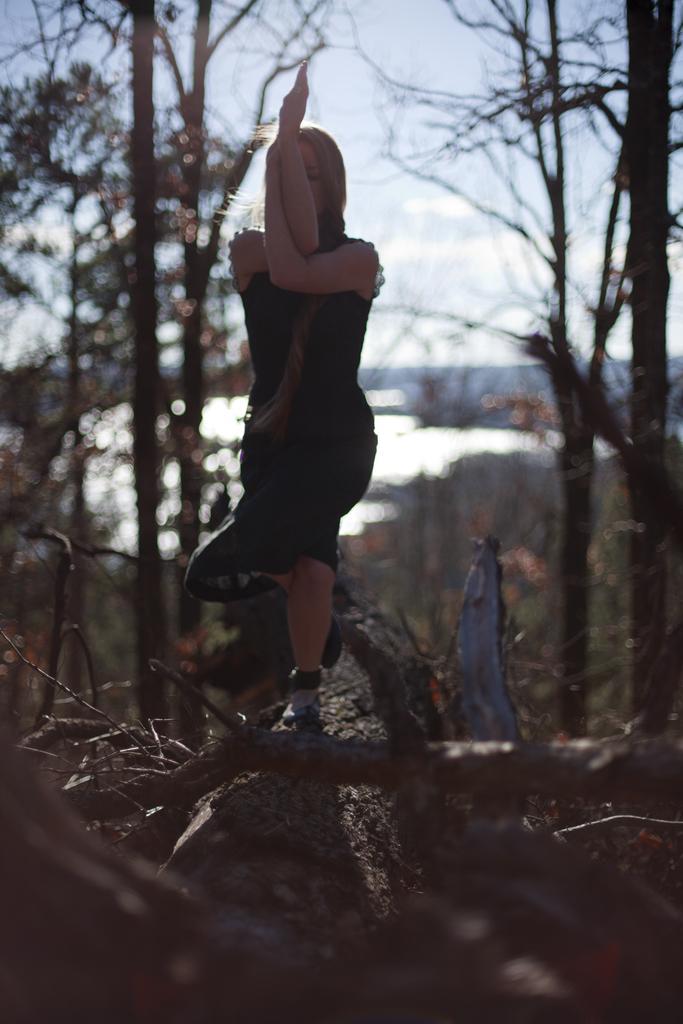How would you summarize this image in a sentence or two? In this image I can see a woman is standing and wearing black color dress. Back I can see trees and water. The sky is in white and blue color. 